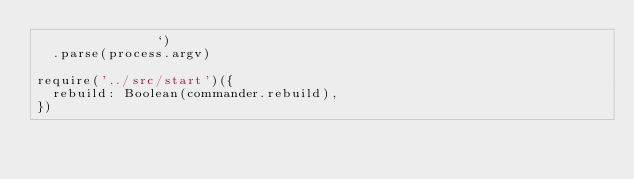<code> <loc_0><loc_0><loc_500><loc_500><_JavaScript_>               `)
  .parse(process.argv)

require('../src/start')({
  rebuild: Boolean(commander.rebuild),
})
</code> 